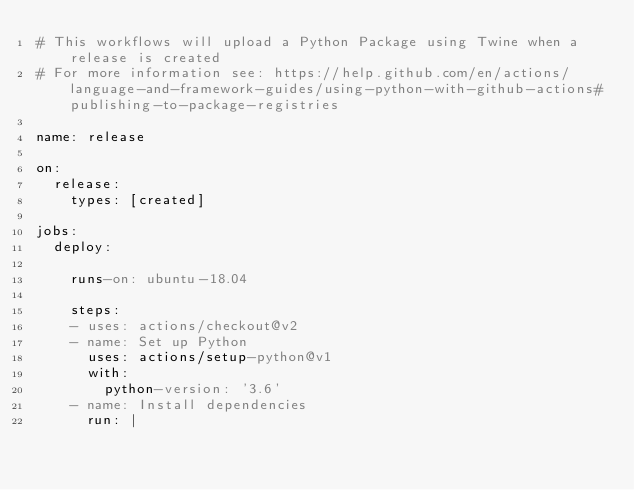<code> <loc_0><loc_0><loc_500><loc_500><_YAML_># This workflows will upload a Python Package using Twine when a release is created
# For more information see: https://help.github.com/en/actions/language-and-framework-guides/using-python-with-github-actions#publishing-to-package-registries

name: release

on:
  release:
    types: [created]

jobs:
  deploy:

    runs-on: ubuntu-18.04

    steps:
    - uses: actions/checkout@v2
    - name: Set up Python
      uses: actions/setup-python@v1
      with:
        python-version: '3.6'
    - name: Install dependencies
      run: |</code> 